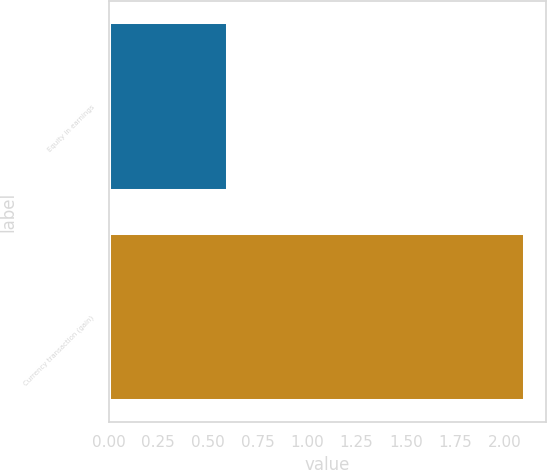<chart> <loc_0><loc_0><loc_500><loc_500><bar_chart><fcel>Equity in earnings<fcel>Currency transaction (gain)<nl><fcel>0.6<fcel>2.1<nl></chart> 